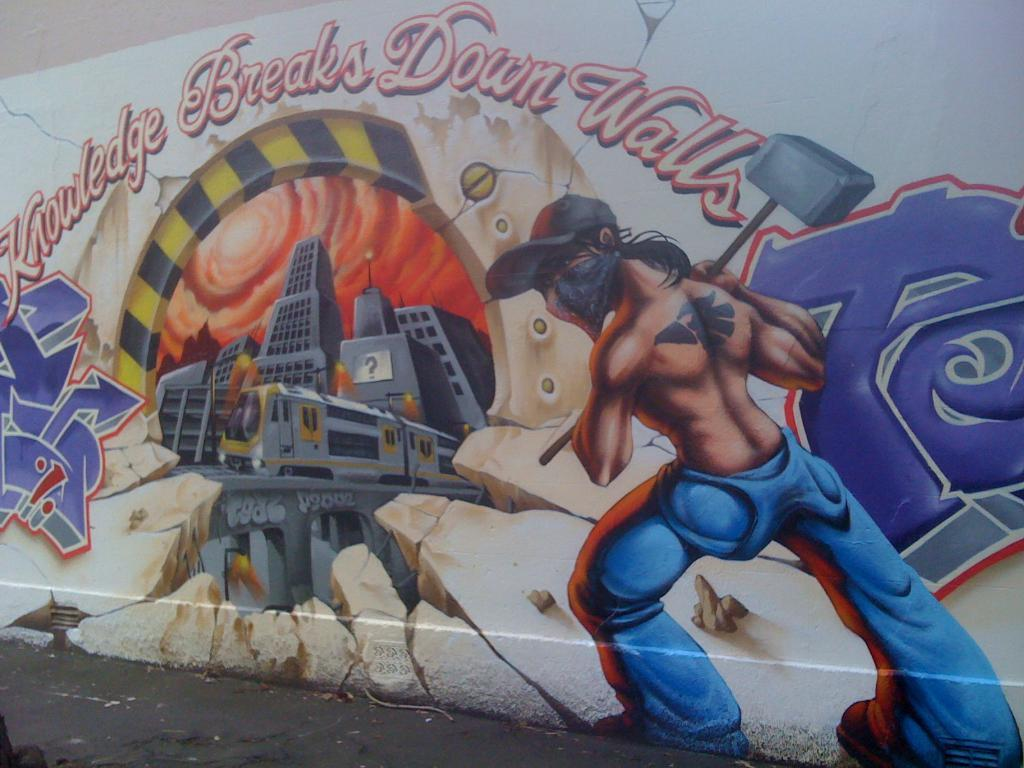What is depicted in the painting in the image? There is a painting of a person holding a hammer in the image. What type of structures can be seen in the image? There are buildings in the image. What part of the natural environment is visible in the image? The sky is visible in the image. What is written on a wall in the image? There is something written on a wall in the image. How many brothers of the person holding the hammer are present in the image? There is no mention of any brothers in the image, and the person holding the hammer is a subject in a painting, not a real person. 